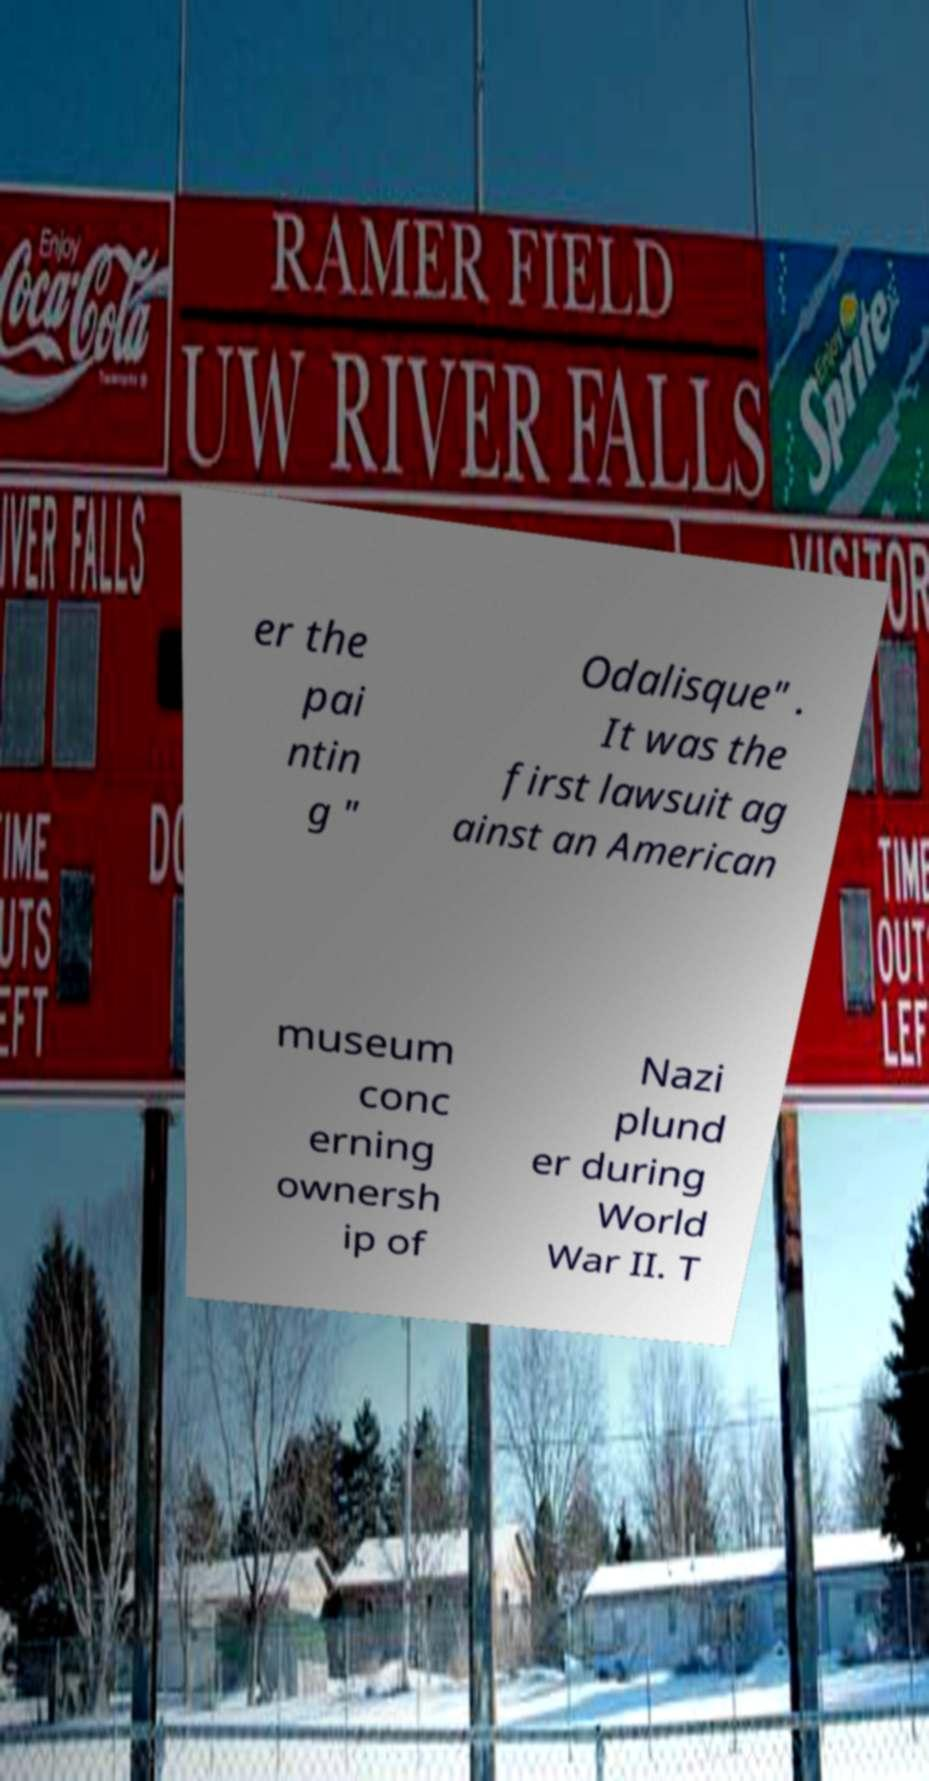Could you assist in decoding the text presented in this image and type it out clearly? er the pai ntin g " Odalisque" . It was the first lawsuit ag ainst an American museum conc erning ownersh ip of Nazi plund er during World War II. T 